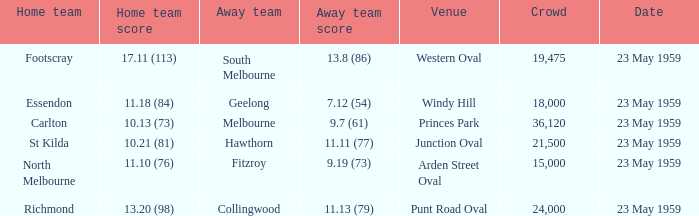What was the home team's score at the game that had a crowd larger than 24,000? 10.13 (73). 